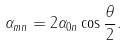<formula> <loc_0><loc_0><loc_500><loc_500>\alpha _ { m n } = 2 \alpha _ { 0 n } \cos { \frac { \theta } { 2 } } .</formula> 